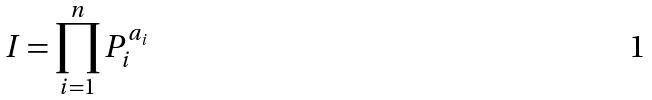Convert formula to latex. <formula><loc_0><loc_0><loc_500><loc_500>I = \prod _ { i = 1 } ^ { n } P _ { i } ^ { a _ { i } }</formula> 